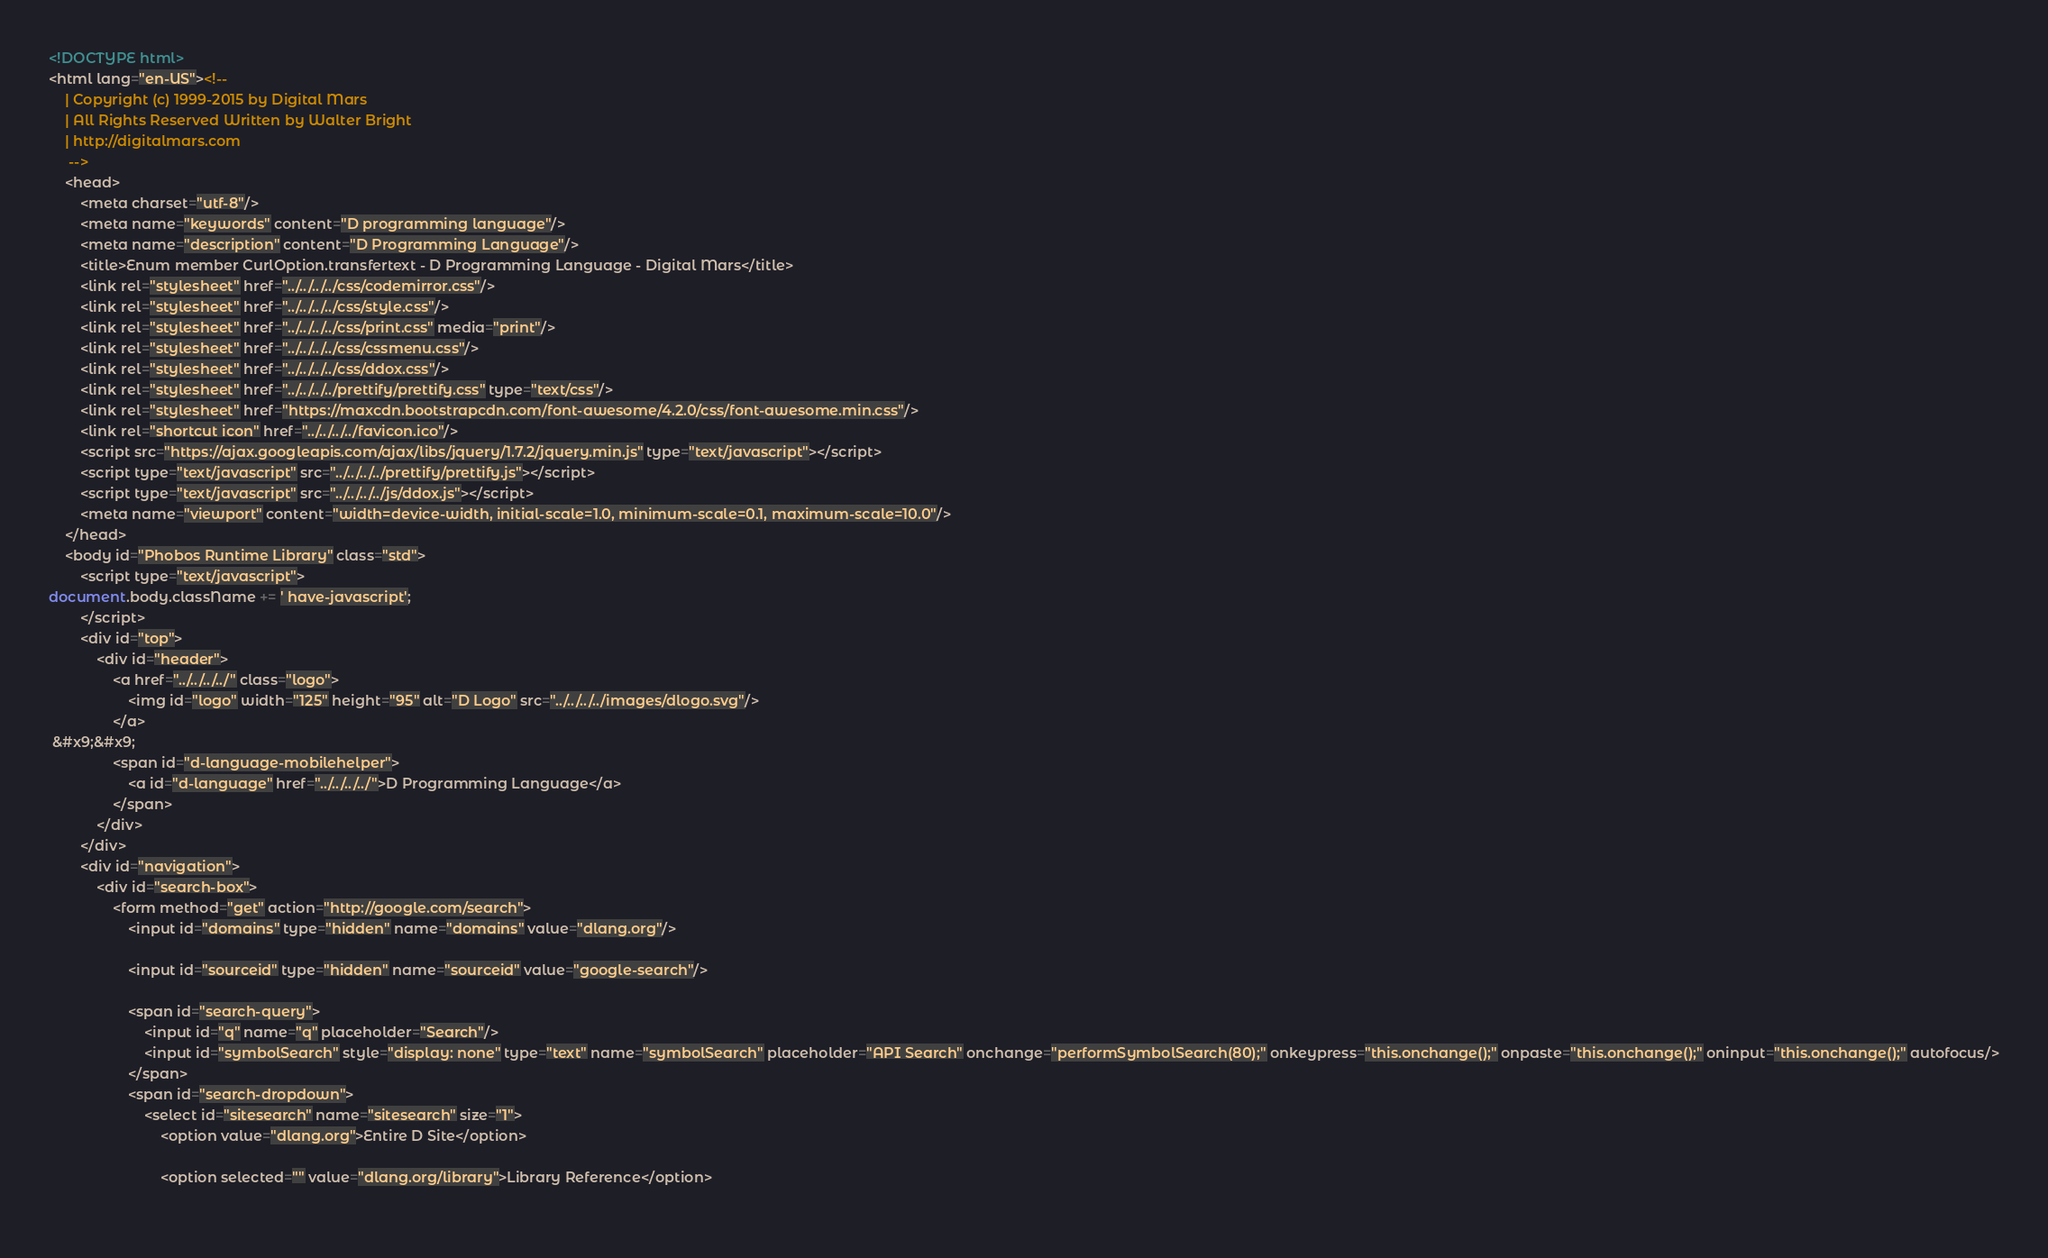<code> <loc_0><loc_0><loc_500><loc_500><_HTML_><!DOCTYPE html>
<html lang="en-US"><!-- 
    | Copyright (c) 1999-2015 by Digital Mars
    | All Rights Reserved Written by Walter Bright
    | http://digitalmars.com
	 -->
	<head>
		<meta charset="utf-8"/>
		<meta name="keywords" content="D programming language"/>
		<meta name="description" content="D Programming Language"/>
		<title>Enum member CurlOption.transfertext - D Programming Language - Digital Mars</title>
		<link rel="stylesheet" href="../../../../css/codemirror.css"/>
		<link rel="stylesheet" href="../../../../css/style.css"/>
		<link rel="stylesheet" href="../../../../css/print.css" media="print"/>
		<link rel="stylesheet" href="../../../../css/cssmenu.css"/>
		<link rel="stylesheet" href="../../../../css/ddox.css"/>
		<link rel="stylesheet" href="../../../../prettify/prettify.css" type="text/css"/>
		<link rel="stylesheet" href="https://maxcdn.bootstrapcdn.com/font-awesome/4.2.0/css/font-awesome.min.css"/>
		<link rel="shortcut icon" href="../../../../favicon.ico"/>
		<script src="https://ajax.googleapis.com/ajax/libs/jquery/1.7.2/jquery.min.js" type="text/javascript"></script>
		<script type="text/javascript" src="../../../../prettify/prettify.js"></script>
		<script type="text/javascript" src="../../../../js/ddox.js"></script>
		<meta name="viewport" content="width=device-width, initial-scale=1.0, minimum-scale=0.1, maximum-scale=10.0"/>
	</head>
	<body id="Phobos Runtime Library" class="std">
		<script type="text/javascript">
document.body.className += ' have-javascript';
		</script>
		<div id="top">
			<div id="header">
				<a href="../../../../" class="logo">
					<img id="logo" width="125" height="95" alt="D Logo" src="../../../../images/dlogo.svg"/>
				</a>
 &#x9;&#x9;
				<span id="d-language-mobilehelper">
					<a id="d-language" href="../../../../">D Programming Language</a>
				</span>
			</div>
		</div>
		<div id="navigation">
			<div id="search-box">
				<form method="get" action="http://google.com/search">
					<input id="domains" type="hidden" name="domains" value="dlang.org"/>
             
					<input id="sourceid" type="hidden" name="sourceid" value="google-search"/>
             
					<span id="search-query">
						<input id="q" name="q" placeholder="Search"/>
						<input id="symbolSearch" style="display: none" type="text" name="symbolSearch" placeholder="API Search" onchange="performSymbolSearch(80);" onkeypress="this.onchange();" onpaste="this.onchange();" oninput="this.onchange();" autofocus/>
					</span>
					<span id="search-dropdown">
						<select id="sitesearch" name="sitesearch" size="1">
							<option value="dlang.org">Entire D Site</option>
                     
							<option selected="" value="dlang.org/library">Library Reference</option>
                     </code> 